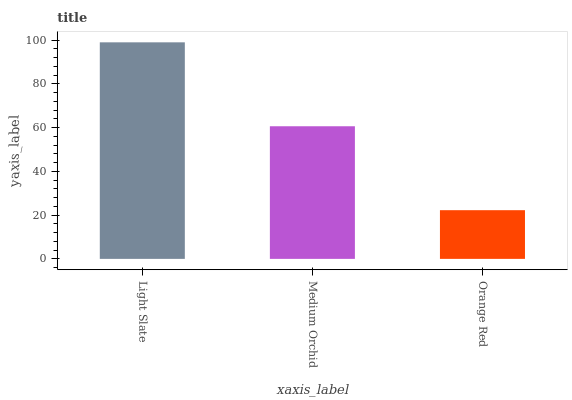Is Orange Red the minimum?
Answer yes or no. Yes. Is Light Slate the maximum?
Answer yes or no. Yes. Is Medium Orchid the minimum?
Answer yes or no. No. Is Medium Orchid the maximum?
Answer yes or no. No. Is Light Slate greater than Medium Orchid?
Answer yes or no. Yes. Is Medium Orchid less than Light Slate?
Answer yes or no. Yes. Is Medium Orchid greater than Light Slate?
Answer yes or no. No. Is Light Slate less than Medium Orchid?
Answer yes or no. No. Is Medium Orchid the high median?
Answer yes or no. Yes. Is Medium Orchid the low median?
Answer yes or no. Yes. Is Orange Red the high median?
Answer yes or no. No. Is Light Slate the low median?
Answer yes or no. No. 